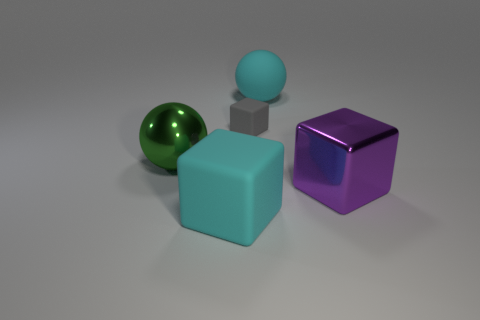Can you describe the colors of the objects in the image? Certainly! There are four objects with distinct colors: a green sphere, a blue cube, a gray smaller cube, and a larger cube with a reflective purple surface. 